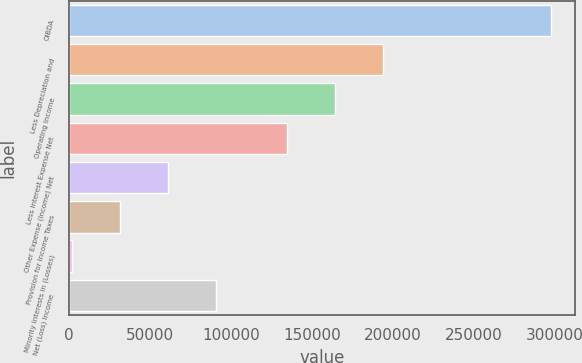<chart> <loc_0><loc_0><loc_500><loc_500><bar_chart><fcel>OIBDA<fcel>Less Depreciation and<fcel>Operating Income<fcel>Less Interest Expense Net<fcel>Other Expense (Income) Net<fcel>Provision for Income Taxes<fcel>Minority Interests in (Losses)<fcel>Net (Loss) Income<nl><fcel>297387<fcel>193834<fcel>164288<fcel>134742<fcel>61020.6<fcel>31474.8<fcel>1929<fcel>90566.4<nl></chart> 